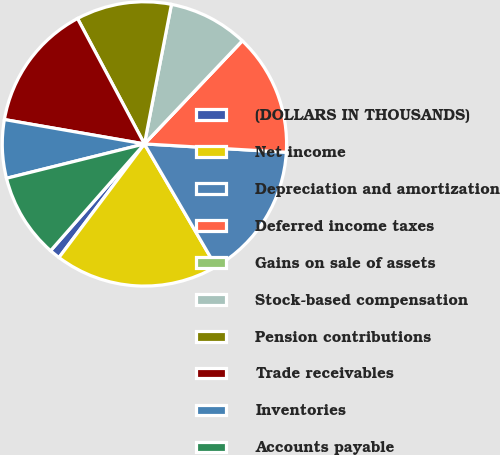Convert chart. <chart><loc_0><loc_0><loc_500><loc_500><pie_chart><fcel>(DOLLARS IN THOUSANDS)<fcel>Net income<fcel>Depreciation and amortization<fcel>Deferred income taxes<fcel>Gains on sale of assets<fcel>Stock-based compensation<fcel>Pension contributions<fcel>Trade receivables<fcel>Inventories<fcel>Accounts payable<nl><fcel>1.21%<fcel>18.67%<fcel>15.66%<fcel>13.85%<fcel>0.0%<fcel>9.04%<fcel>10.84%<fcel>14.46%<fcel>6.63%<fcel>9.64%<nl></chart> 